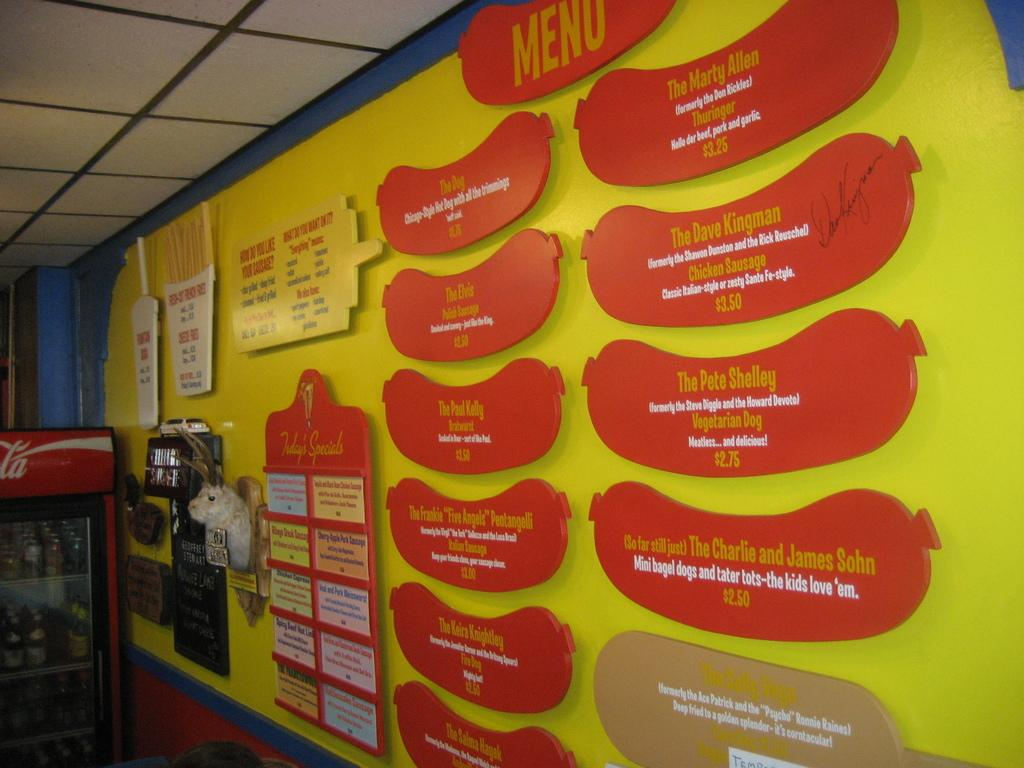<image>
Render a clear and concise summary of the photo. A sign that says menu shaped like a hot dog sits on a yellow wall with options under it. 